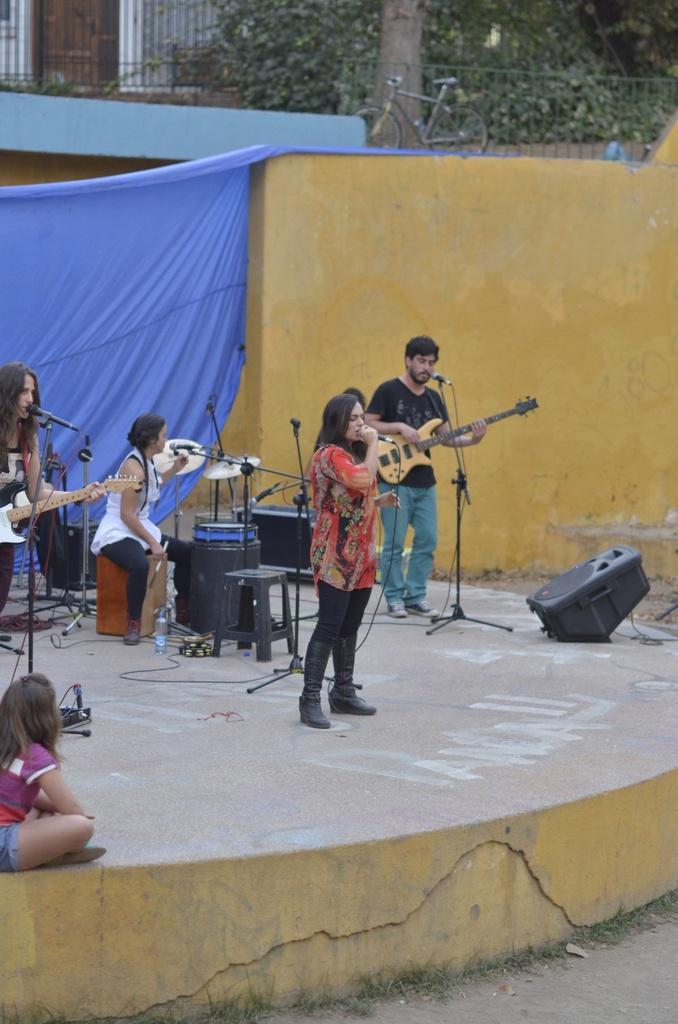Can you describe this image briefly? In this image I see the stage on which there are few people, in which these 2 of them are holding guitars in their hands and this woman is holding a mic in her hand and I see the drums over here and I see a child who is sitting over here and in the background I see the wall, blue color curtain, a cycle over here, leaves and I see the black color thing over here. 